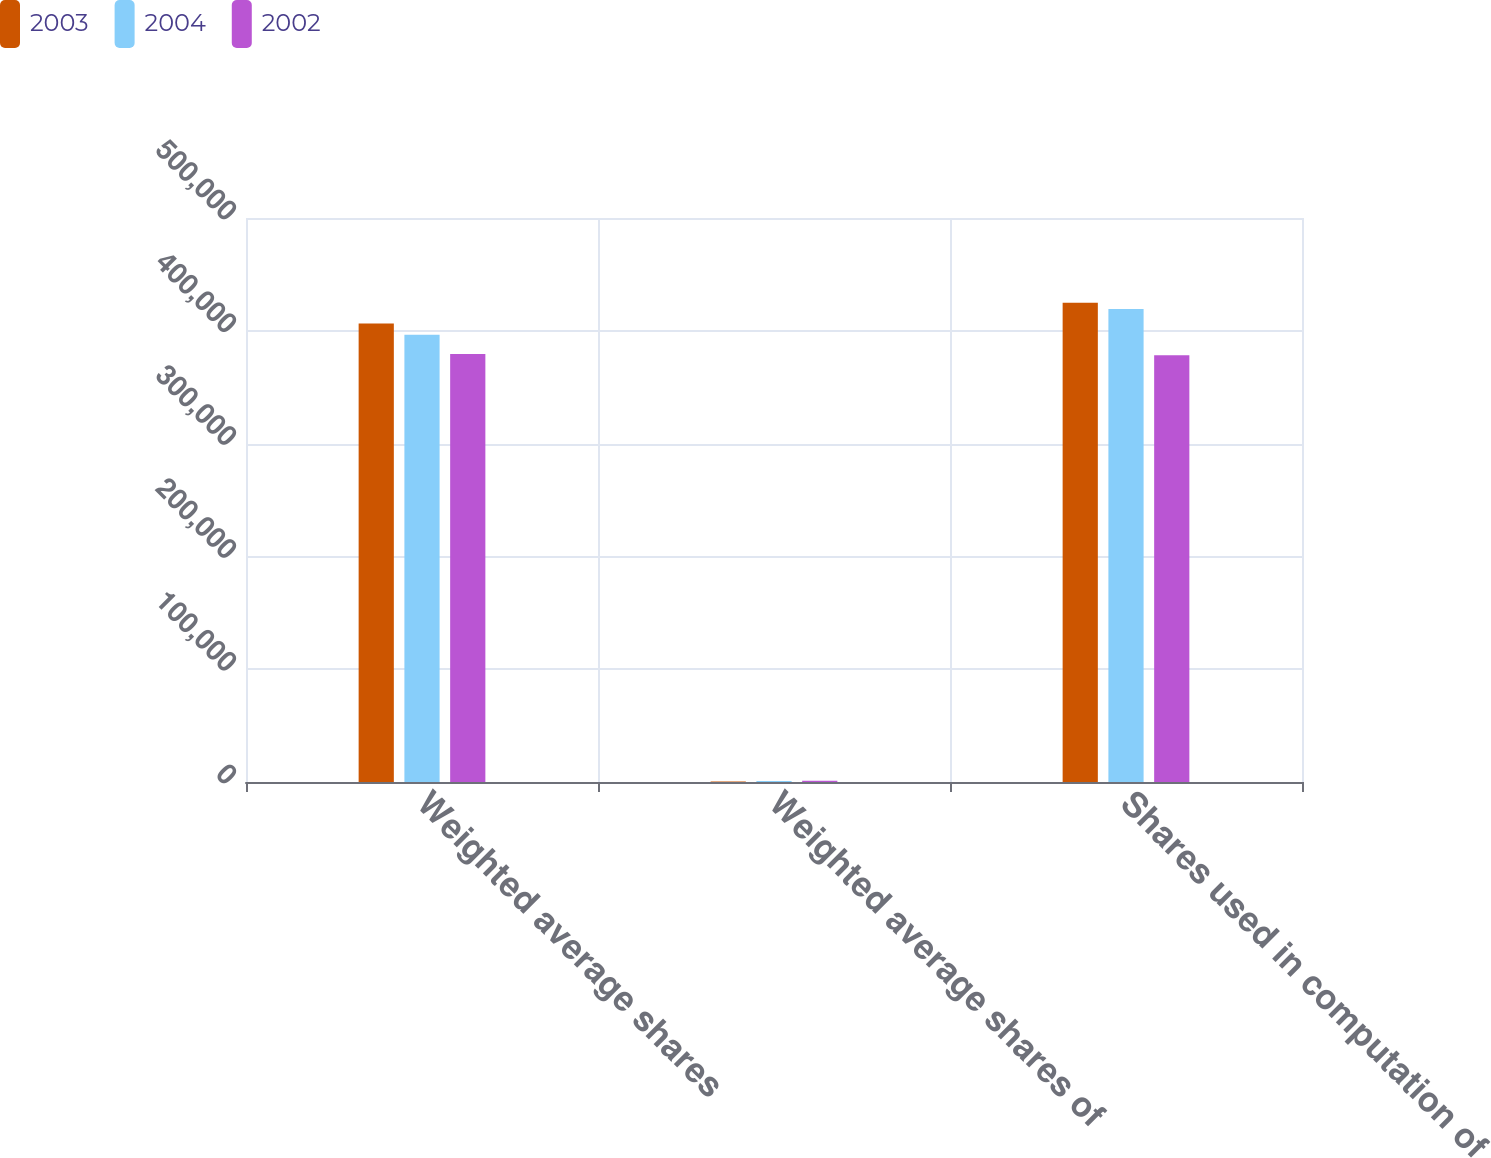<chart> <loc_0><loc_0><loc_500><loc_500><stacked_bar_chart><ecel><fcel>Weighted average shares<fcel>Weighted average shares of<fcel>Shares used in computation of<nl><fcel>2003<fcel>406480<fcel>554<fcel>424757<nl><fcel>2004<fcel>396389<fcel>910<fcel>419352<nl><fcel>2002<fcel>379494<fcel>1131<fcel>378363<nl></chart> 